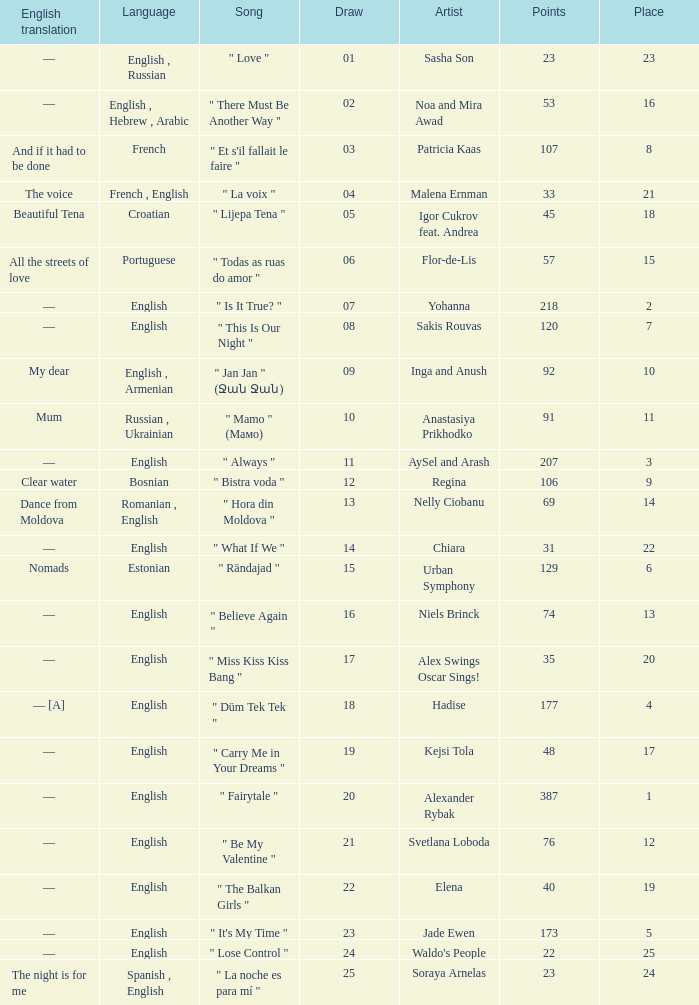Parse the full table. {'header': ['English translation', 'Language', 'Song', 'Draw', 'Artist', 'Points', 'Place'], 'rows': [['—', 'English , Russian', '" Love "', '01', 'Sasha Son', '23', '23'], ['—', 'English , Hebrew , Arabic', '" There Must Be Another Way "', '02', 'Noa and Mira Awad', '53', '16'], ['And if it had to be done', 'French', '" Et s\'il fallait le faire "', '03', 'Patricia Kaas', '107', '8'], ['The voice', 'French , English', '" La voix "', '04', 'Malena Ernman', '33', '21'], ['Beautiful Tena', 'Croatian', '" Lijepa Tena "', '05', 'Igor Cukrov feat. Andrea', '45', '18'], ['All the streets of love', 'Portuguese', '" Todas as ruas do amor "', '06', 'Flor-de-Lis', '57', '15'], ['—', 'English', '" Is It True? "', '07', 'Yohanna', '218', '2'], ['—', 'English', '" This Is Our Night "', '08', 'Sakis Rouvas', '120', '7'], ['My dear', 'English , Armenian', '" Jan Jan " (Ջան Ջան)', '09', 'Inga and Anush', '92', '10'], ['Mum', 'Russian , Ukrainian', '" Mamo " (Мамо)', '10', 'Anastasiya Prikhodko', '91', '11'], ['—', 'English', '" Always "', '11', 'AySel and Arash', '207', '3'], ['Clear water', 'Bosnian', '" Bistra voda "', '12', 'Regina', '106', '9'], ['Dance from Moldova', 'Romanian , English', '" Hora din Moldova "', '13', 'Nelly Ciobanu', '69', '14'], ['—', 'English', '" What If We "', '14', 'Chiara', '31', '22'], ['Nomads', 'Estonian', '" Rändajad "', '15', 'Urban Symphony', '129', '6'], ['—', 'English', '" Believe Again "', '16', 'Niels Brinck', '74', '13'], ['—', 'English', '" Miss Kiss Kiss Bang "', '17', 'Alex Swings Oscar Sings!', '35', '20'], ['— [A]', 'English', '" Düm Tek Tek "', '18', 'Hadise', '177', '4'], ['—', 'English', '" Carry Me in Your Dreams "', '19', 'Kejsi Tola', '48', '17'], ['—', 'English', '" Fairytale "', '20', 'Alexander Rybak', '387', '1'], ['—', 'English', '" Be My Valentine "', '21', 'Svetlana Loboda', '76', '12'], ['—', 'English', '" The Balkan Girls "', '22', 'Elena', '40', '19'], ['—', 'English', '" It\'s My Time "', '23', 'Jade Ewen', '173', '5'], ['—', 'English', '" Lose Control "', '24', "Waldo's People", '22', '25'], ['The night is for me', 'Spanish , English', '" La noche es para mí "', '25', 'Soraya Arnelas', '23', '24']]} What was the average place for the song that had 69 points and a draw smaller than 13? None. 